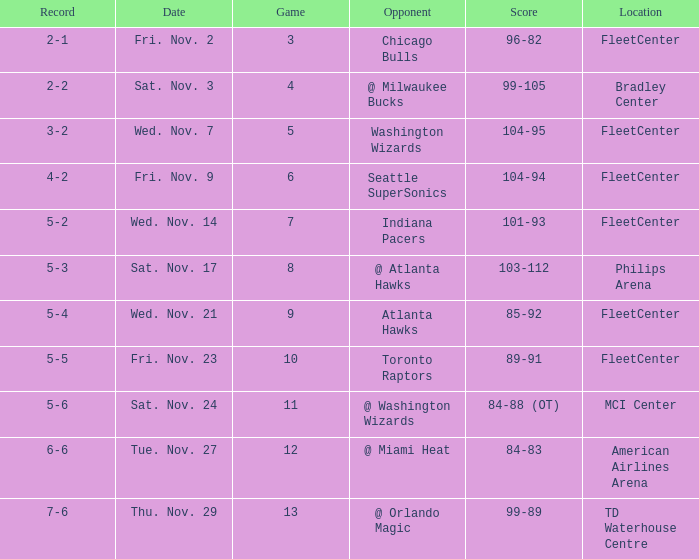Which opponent has a score of 84-88 (ot)? @ Washington Wizards. 